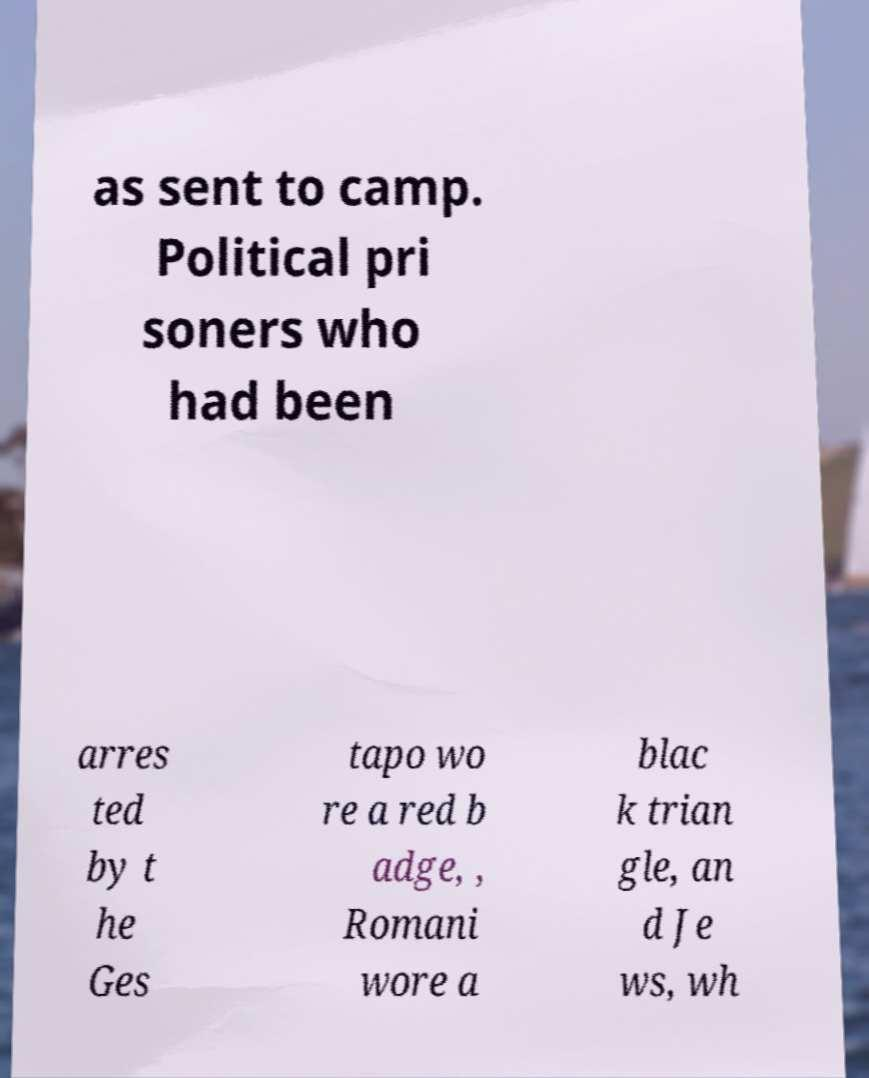Can you accurately transcribe the text from the provided image for me? as sent to camp. Political pri soners who had been arres ted by t he Ges tapo wo re a red b adge, , Romani wore a blac k trian gle, an d Je ws, wh 